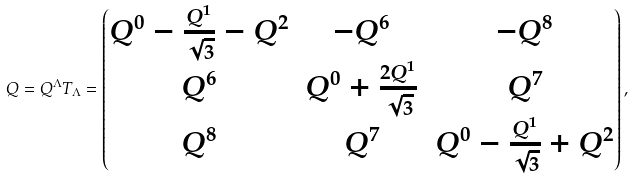Convert formula to latex. <formula><loc_0><loc_0><loc_500><loc_500>Q = Q ^ { \Lambda } T _ { \Lambda } = \begin{pmatrix} Q ^ { 0 } - \frac { Q ^ { 1 } } { \sqrt { 3 } } - Q ^ { 2 } & - Q ^ { 6 } & - Q ^ { 8 } \\ Q ^ { 6 } & Q ^ { 0 } + \frac { 2 Q ^ { 1 } } { \sqrt { 3 } } & Q ^ { 7 } \\ Q ^ { 8 } & Q ^ { 7 } & Q ^ { 0 } - \frac { Q ^ { 1 } } { \sqrt { 3 } } + Q ^ { 2 } \end{pmatrix} ,</formula> 